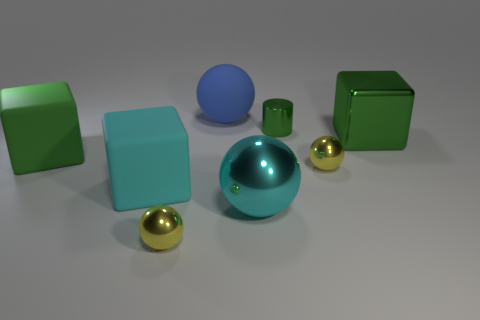There is a cylinder that is the same color as the big metal block; what size is it?
Offer a terse response. Small. The matte thing that is the same color as the tiny cylinder is what shape?
Your answer should be very brief. Cube. Are there any other things of the same color as the tiny cylinder?
Provide a short and direct response. Yes. Does the tiny cylinder have the same color as the shiny cube?
Your answer should be compact. Yes. How many cylinders have the same color as the metal block?
Offer a terse response. 1. Are there more tiny metal cylinders than large yellow rubber spheres?
Give a very brief answer. Yes. There is a thing that is to the right of the tiny green cylinder and behind the large green matte object; what size is it?
Offer a terse response. Large. Is the small yellow ball that is right of the cyan sphere made of the same material as the big green thing on the right side of the green cylinder?
Provide a short and direct response. Yes. The blue object that is the same size as the cyan shiny thing is what shape?
Keep it short and to the point. Sphere. Are there fewer tiny metallic cylinders than small things?
Your answer should be compact. Yes. 